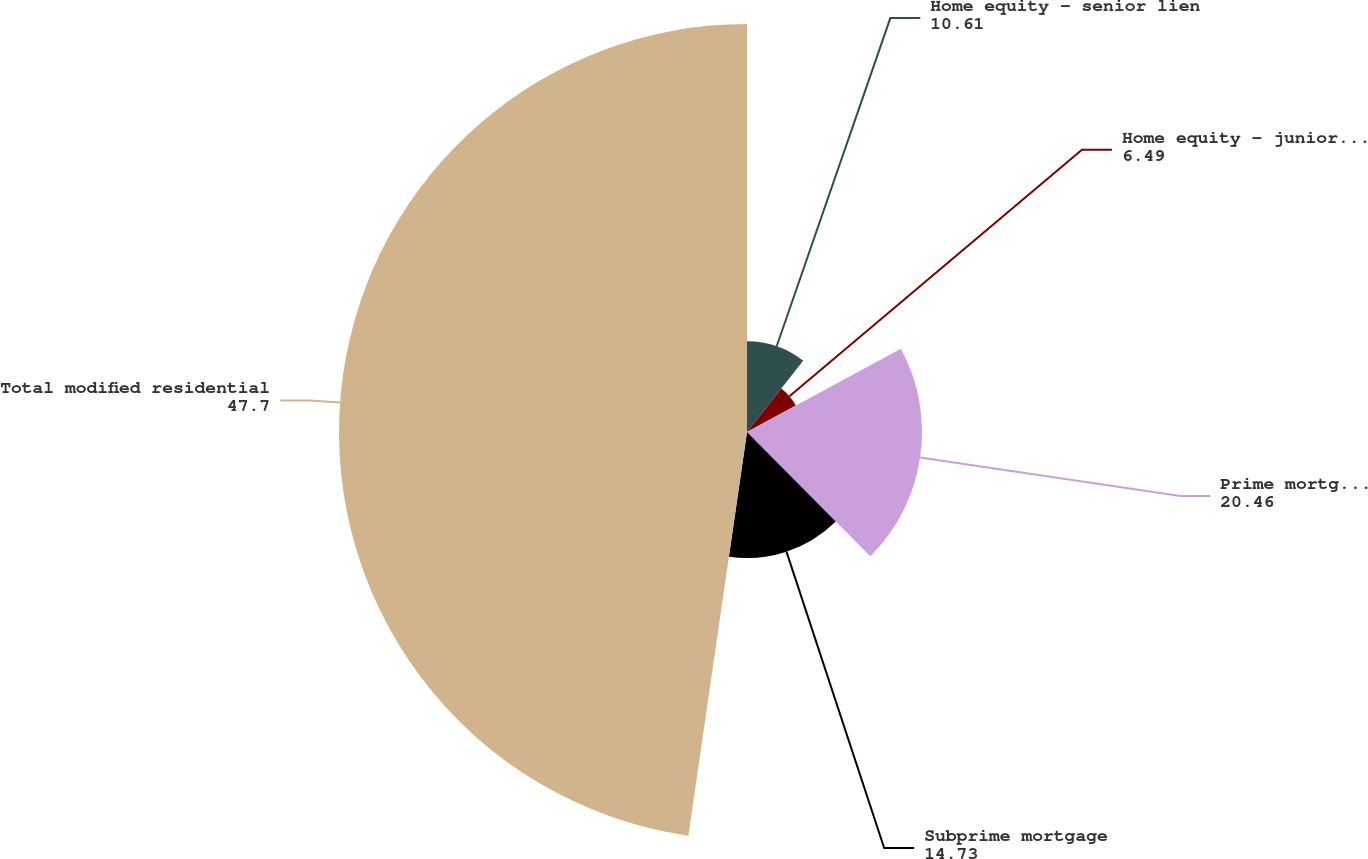Convert chart. <chart><loc_0><loc_0><loc_500><loc_500><pie_chart><fcel>Home equity - senior lien<fcel>Home equity - junior lien<fcel>Prime mortgage including<fcel>Subprime mortgage<fcel>Total modified residential<nl><fcel>10.61%<fcel>6.49%<fcel>20.46%<fcel>14.73%<fcel>47.7%<nl></chart> 